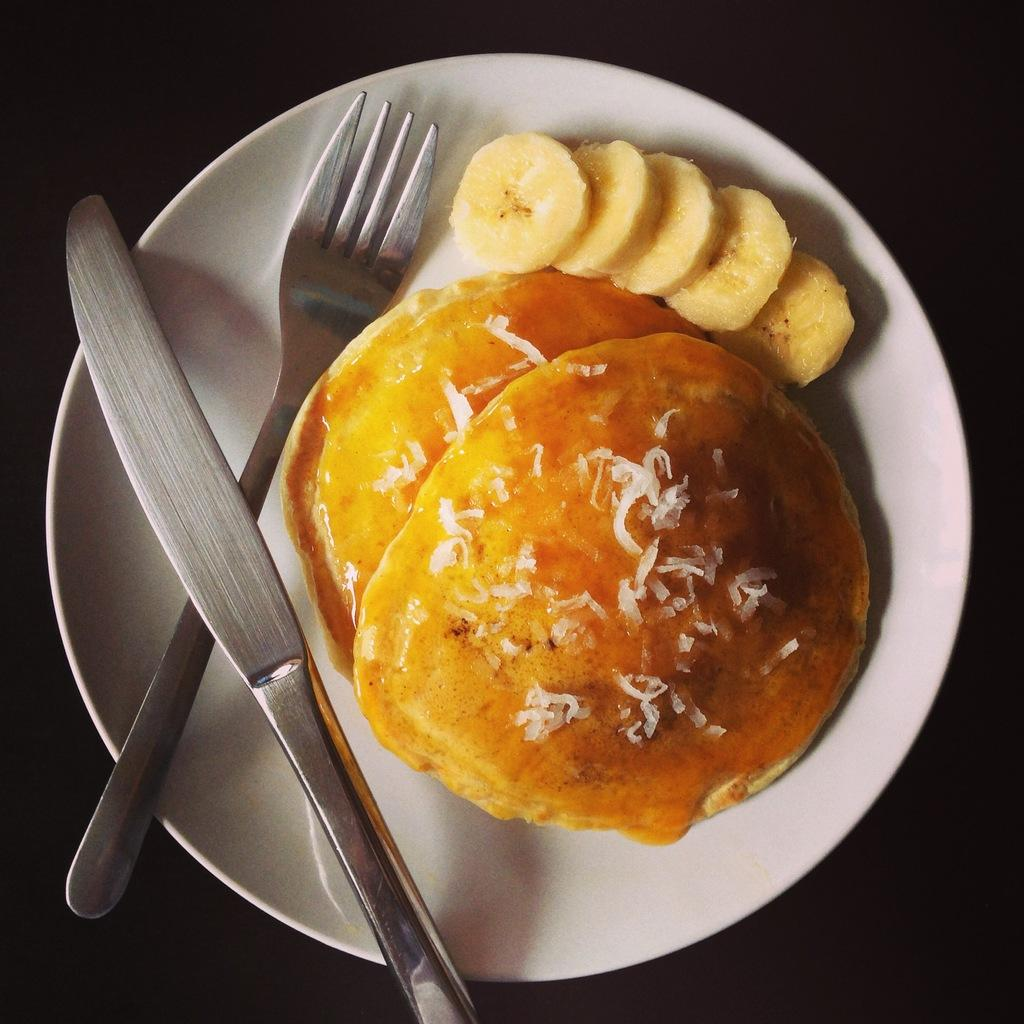What type of food is visible in the image? There are pancakes in the image. What is placed on top of the pancakes? There are banana slices in the image. What utensils are present in the image? There is a fork and a knife in the image. What color is the plate in the image? The plate is white. What is the color of the background in the image? There is a black background in the image. What type of game is being played in the image? There is no game being played in the image; it features pancakes with banana slices, utensils, and a white plate on a black background. What type of rod is used to hold up the jeans in the image? There are no jeans or rods present in the image. 